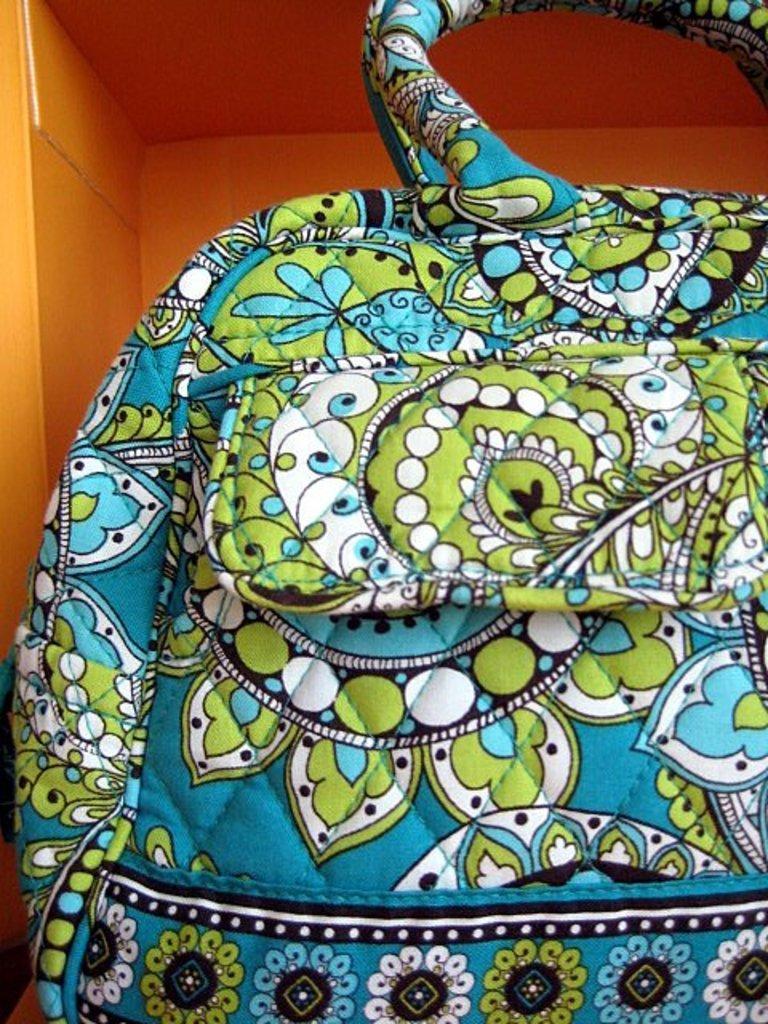Describe this image in one or two sentences. In the image there is a bag and behind the bag there is a cupboard. 